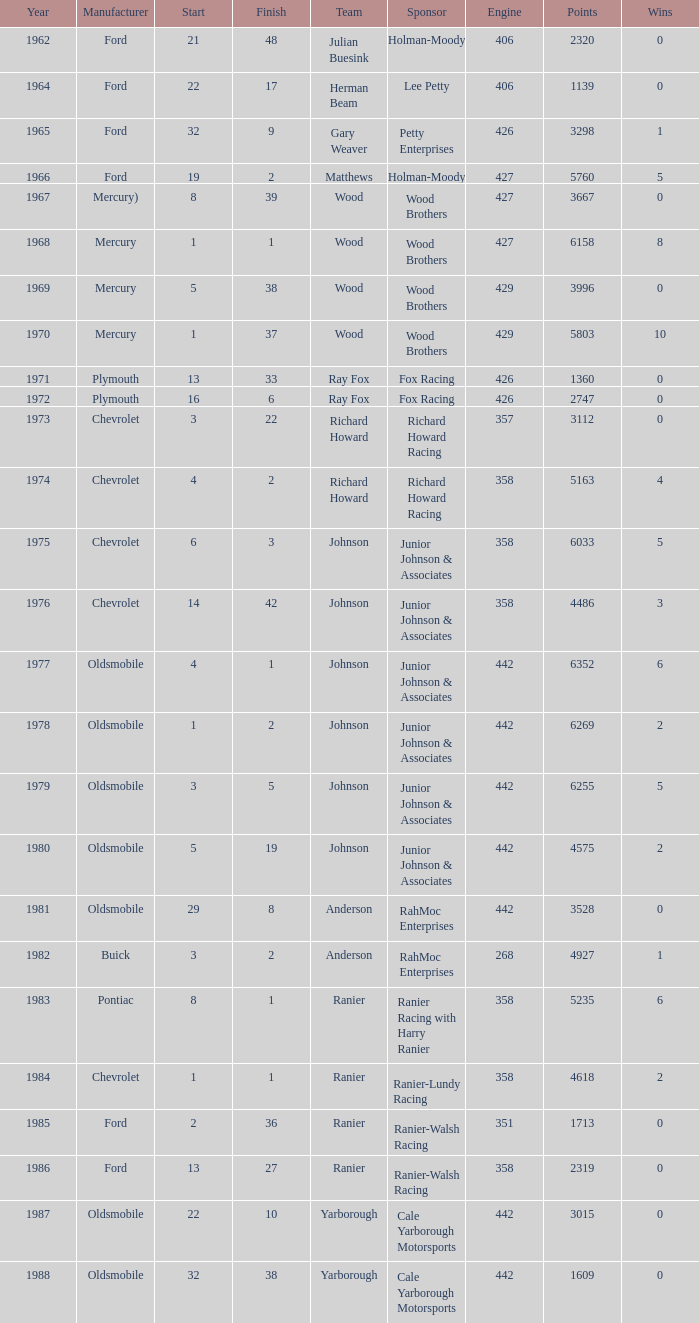What is the smallest finish time for a race where start was less than 3, buick was the manufacturer, and the race was held after 1978? None. 